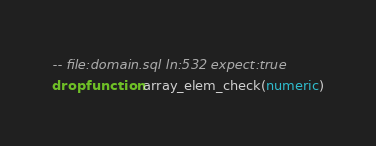<code> <loc_0><loc_0><loc_500><loc_500><_SQL_>-- file:domain.sql ln:532 expect:true
drop function array_elem_check(numeric)
</code> 